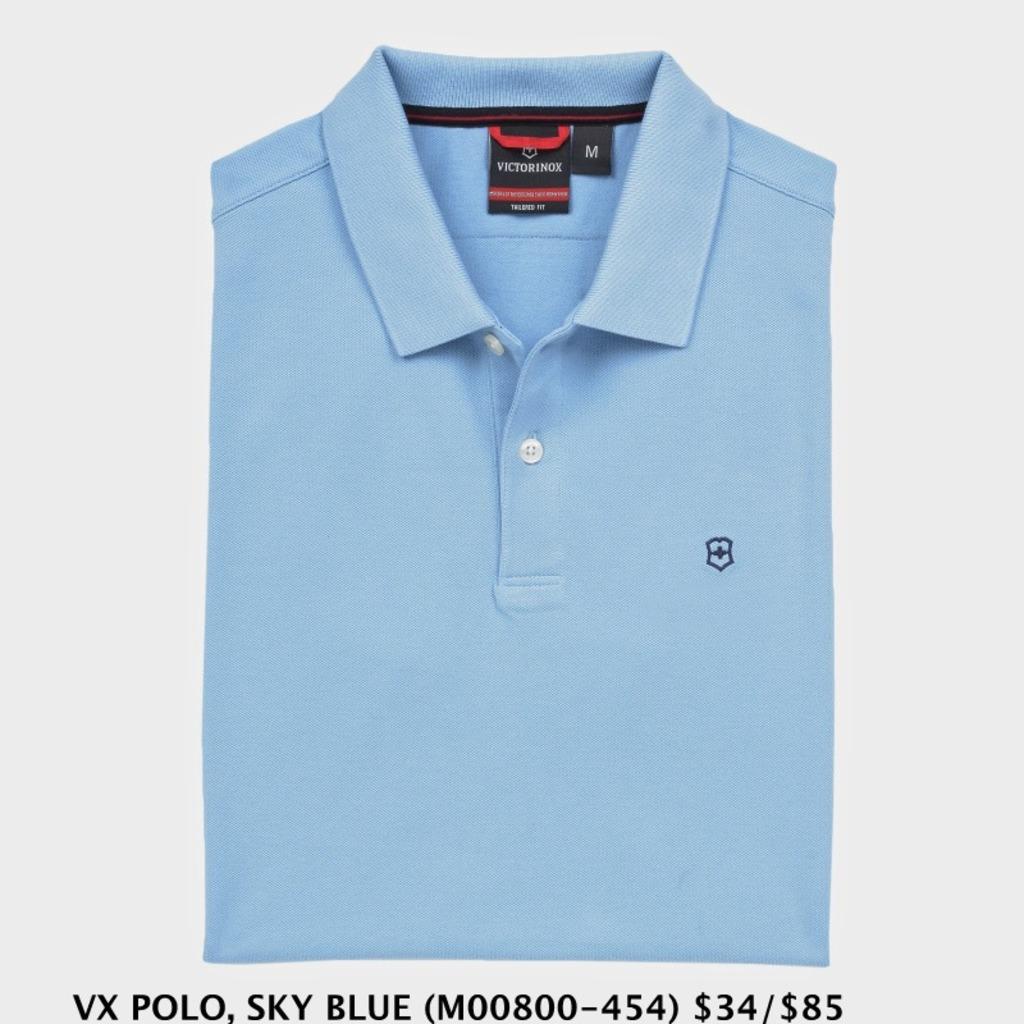What is the range price of the shirt?
Offer a very short reply. 34/85. What size is this shirt?
Your response must be concise. M. 